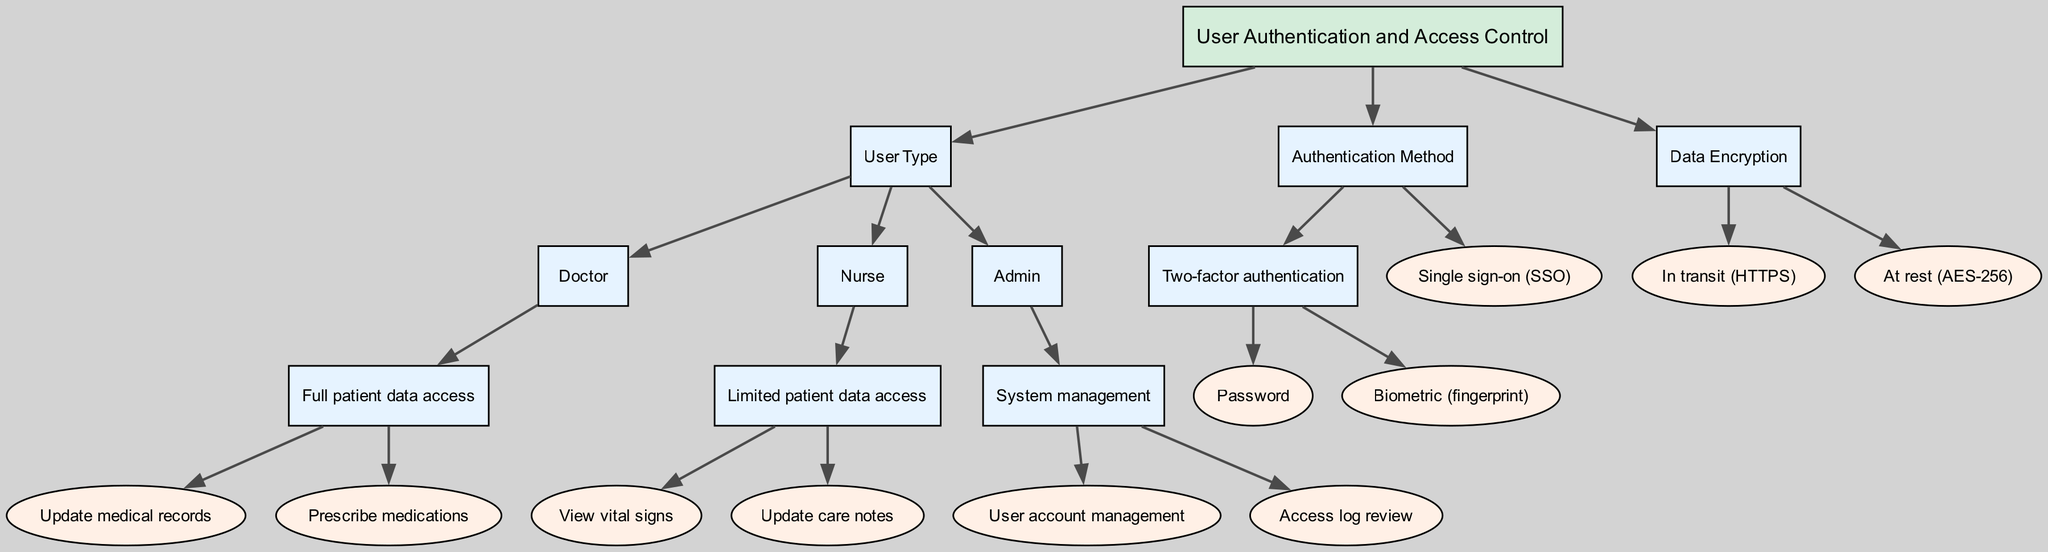What is the root node of this decision tree? The root node represents the overall topic of the decision tree. By examining the top section of the diagram, we can see the label that describes it as "User Authentication and Access Control."
Answer: User Authentication and Access Control How many user types are there? Counting the child nodes under the "User Type" node, we see three distinct roles: Doctor, Nurse, and Admin. Therefore, the total number of user types is three.
Answer: 3 What type of access does a Nurse have? Looking under the "Nurse" node in the diagram, we find that it specifies "Limited patient data access." This explicitly outlines the level of access for this user type.
Answer: Limited patient data access Which authentication method includes biometric verification? Under the "Authentication Method" section, the "Two-factor authentication" node provides sub-nodes that highlight "Password" and "Biometric (fingerprint)." This indicates that biometric verification is part of two-factor authentication.
Answer: Two-factor authentication How many actions can a Doctor perform with full patient data access? By reviewing the branches of the "Full patient data access" node under "Doctor," we observe two possible actions listed: "Update medical records" and "Prescribe medications." Therefore, the total number of actions a Doctor can perform is two.
Answer: 2 What encryption standard is specified for data at rest? In the "Data Encryption" section, one of the child nodes specifies "At rest (AES-256)." This indicates that AES-256 is the encryption standard implemented for storing data securely.
Answer: AES-256 What is one task the Admin can perform related to system management? Examining the "Admin" node and its child area titled "System management," we identify two specific tasks, with one being "User account management." This represents a specific capability of Admin users.
Answer: User account management Which user type can prescribe medications? By looking closely at the "Doctor" node in the diagram, we see that "Prescribe medications" is listed as one of the actions under "Full patient data access." Thus, the user type that can perform this action is "Doctor."
Answer: Doctor What authentication method allows logging in without a separate password for each service? In the "Authentication Method" section, the node labeled "Single sign-on (SSO)" indicates that this method permits users to authenticate themselves across multiple services without needing different passwords for each.
Answer: Single sign-on How are data transmitted in the context of encryption? Referring to the "Data Encryption" section, we find the node "In transit (HTTPS)," which indicates that data is transmitted securely using the HTTPS protocol.
Answer: In transit (HTTPS) 